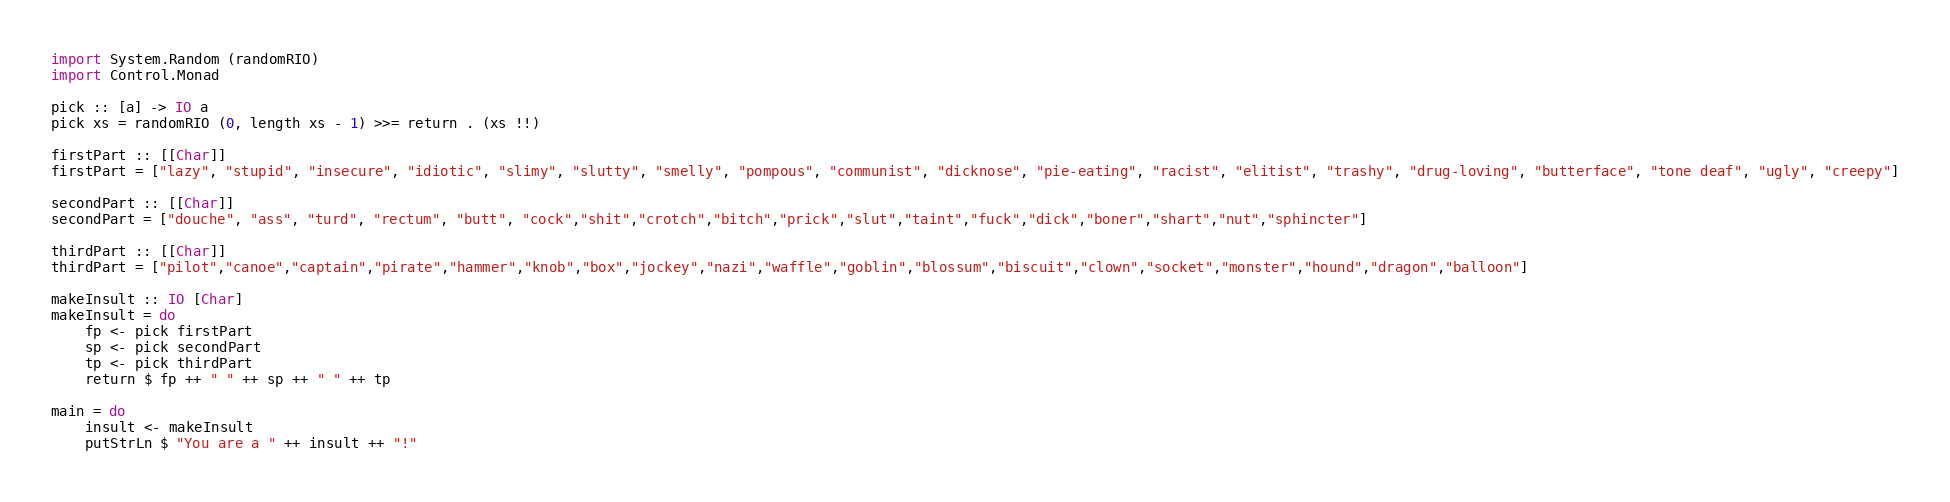<code> <loc_0><loc_0><loc_500><loc_500><_Haskell_>import System.Random (randomRIO)
import Control.Monad

pick :: [a] -> IO a
pick xs = randomRIO (0, length xs - 1) >>= return . (xs !!)

firstPart :: [[Char]]
firstPart = ["lazy", "stupid", "insecure", "idiotic", "slimy", "slutty", "smelly", "pompous", "communist", "dicknose", "pie-eating", "racist", "elitist", "trashy", "drug-loving", "butterface", "tone deaf", "ugly", "creepy"]

secondPart :: [[Char]]
secondPart = ["douche", "ass", "turd", "rectum", "butt", "cock","shit","crotch","bitch","prick","slut","taint","fuck","dick","boner","shart","nut","sphincter"]

thirdPart :: [[Char]]
thirdPart = ["pilot","canoe","captain","pirate","hammer","knob","box","jockey","nazi","waffle","goblin","blossum","biscuit","clown","socket","monster","hound","dragon","balloon"]

makeInsult :: IO [Char]
makeInsult = do
    fp <- pick firstPart
    sp <- pick secondPart
    tp <- pick thirdPart
    return $ fp ++ " " ++ sp ++ " " ++ tp

main = do
    insult <- makeInsult
    putStrLn $ "You are a " ++ insult ++ "!"














</code> 